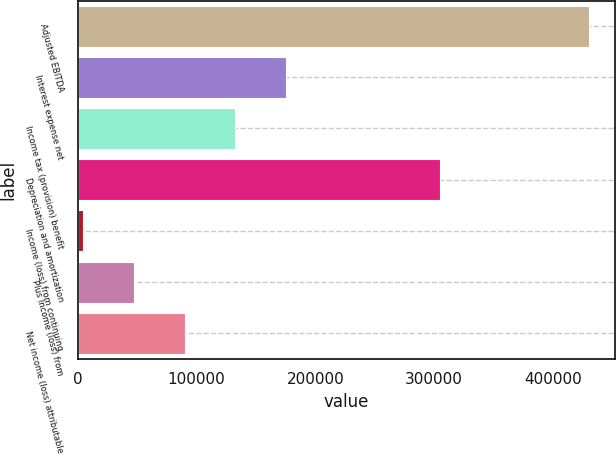<chart> <loc_0><loc_0><loc_500><loc_500><bar_chart><fcel>Adjusted EBITDA<fcel>Interest expense net<fcel>Income tax (provision) benefit<fcel>Depreciation and amortization<fcel>Income (loss) from continuing<fcel>Plus Income (loss) from<fcel>Net income (loss) attributable<nl><fcel>430574<fcel>175048<fcel>132460<fcel>304642<fcel>4697<fcel>47284.7<fcel>89872.4<nl></chart> 